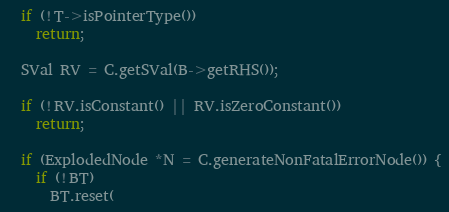Convert code to text. <code><loc_0><loc_0><loc_500><loc_500><_C++_>  if (!T->isPointerType())
    return;

  SVal RV = C.getSVal(B->getRHS());

  if (!RV.isConstant() || RV.isZeroConstant())
    return;

  if (ExplodedNode *N = C.generateNonFatalErrorNode()) {
    if (!BT)
      BT.reset(</code> 